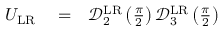<formula> <loc_0><loc_0><loc_500><loc_500>\begin{array} { r l r } { U _ { L R } } & = } & { \mathcal { D } _ { 2 } ^ { L R } \left ( \frac { \pi } { 2 } \right ) \mathcal { D } _ { 3 } ^ { L R } \left ( \frac { \pi } { 2 } \right ) } \end{array}</formula> 